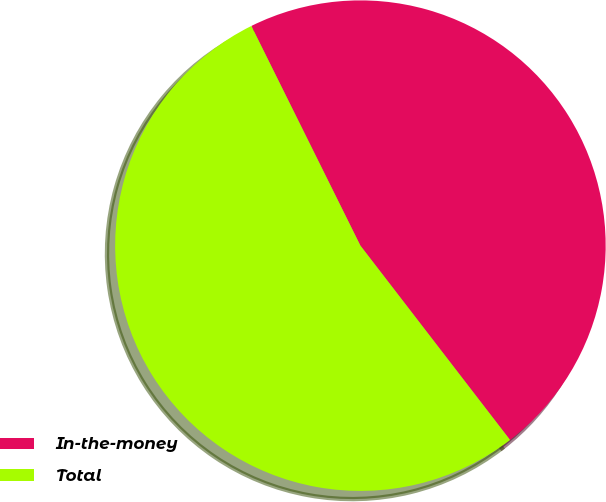Convert chart. <chart><loc_0><loc_0><loc_500><loc_500><pie_chart><fcel>In-the-money<fcel>Total<nl><fcel>46.89%<fcel>53.11%<nl></chart> 